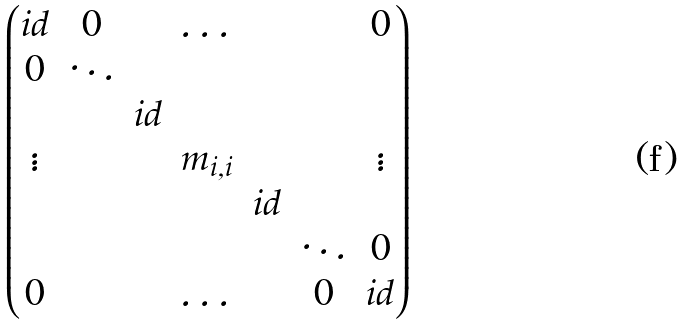<formula> <loc_0><loc_0><loc_500><loc_500>\begin{pmatrix} i d & 0 & & \dots & & & 0 \\ 0 & \ddots & & & & & \\ & & i d & & & & \\ \vdots & & & m _ { i , i } & & & \vdots \\ & & & & i d & & \\ & & & & & \ddots & 0 \\ 0 & & & \dots & & 0 & i d \end{pmatrix}</formula> 